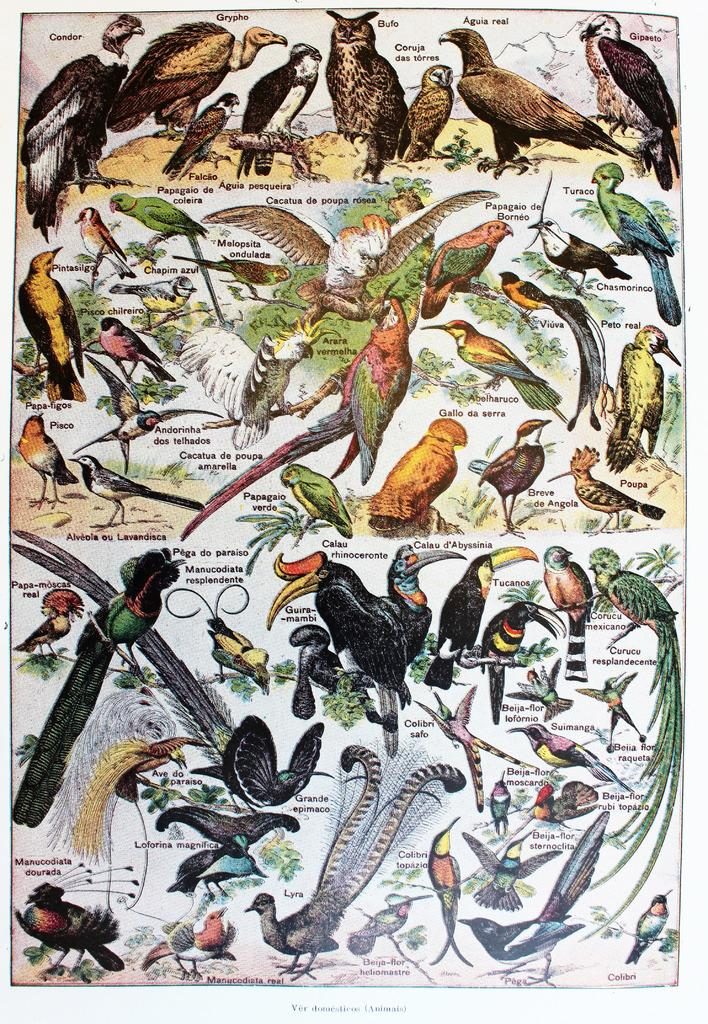What type of visual is the image? The image is a poster. What kind of animals are featured in the poster? There are different types of birds in the image. Is there any text present on the poster? Yes, there is text present in the image. What position does the goat play in the baseball game depicted in the image? There is no baseball game or goat present in the image; it features a poster with different types of birds and text. 